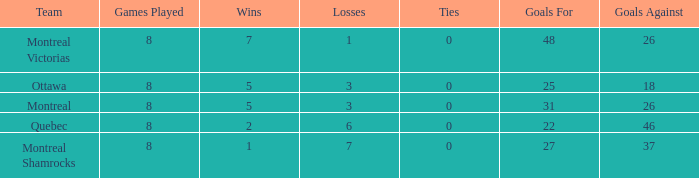For teams with more than 0 ties and goals against of 37, how many wins were tallied? None. 